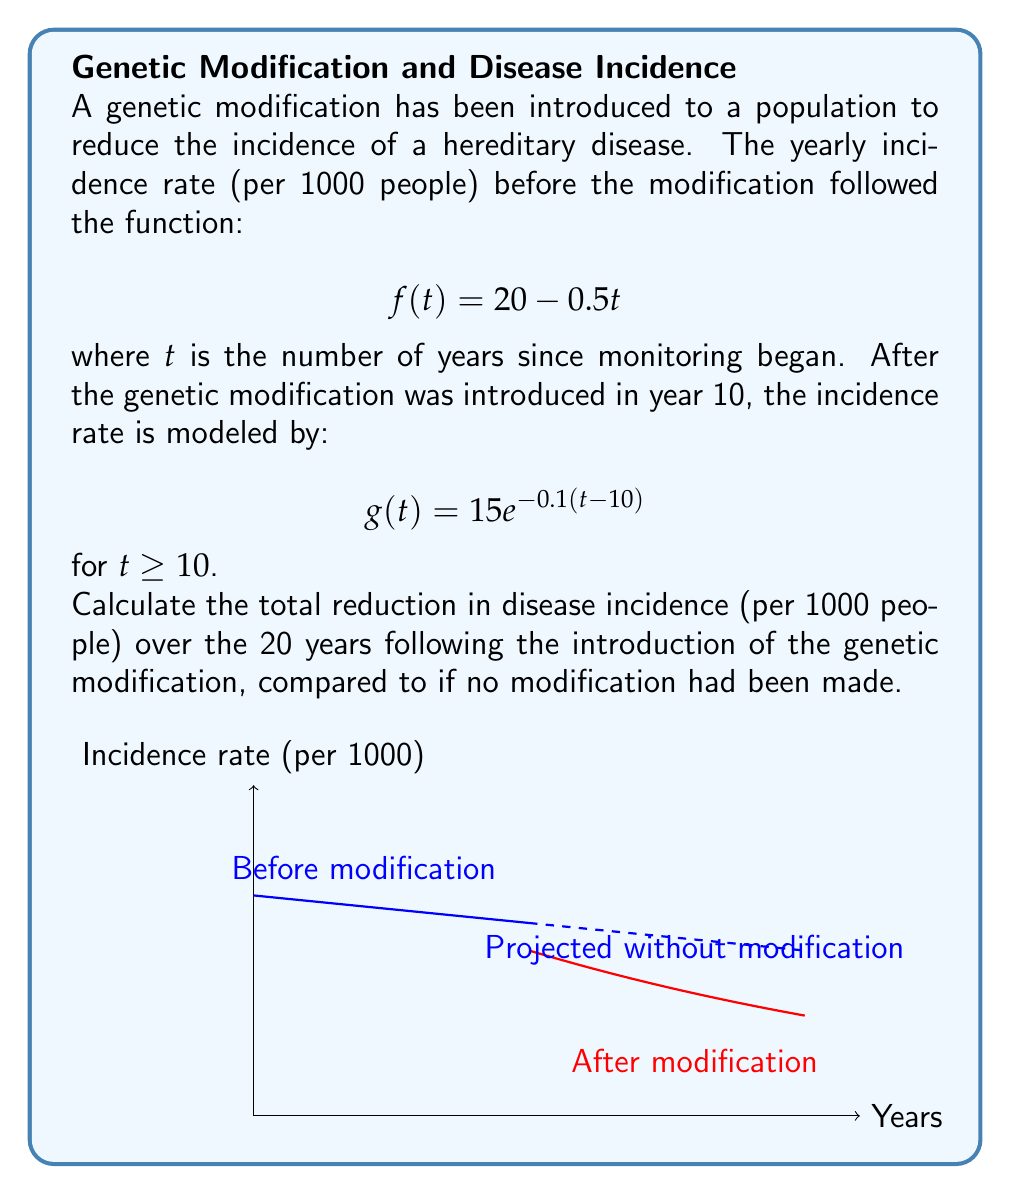What is the answer to this math problem? Let's approach this step-by-step:

1) First, we need to calculate the total incidence over 20 years if no modification had been made. This is the integral of $f(t)$ from $t=10$ to $t=30$:

   $$\int_{10}^{30} (20 - 0.5t) dt = [20t - 0.25t^2]_{10}^{30} = (600 - 225) - (200 - 25) = 200$$

2) Now, we calculate the total incidence over 20 years with the modification. This is the integral of $g(t)$ from $t=10$ to $t=30$:

   $$\int_{10}^{30} 15e^{-0.1(t-10)} dt = -150[e^{-0.1(t-10)}]_{10}^{30} = -150(e^{-2} - 1) \approx 127.88$$

3) The reduction in incidence is the difference between these two values:

   $$200 - 127.88 = 72.12$$

Therefore, the total reduction in disease incidence over 20 years is approximately 72.12 per 1000 people.
Answer: 72.12 per 1000 people 